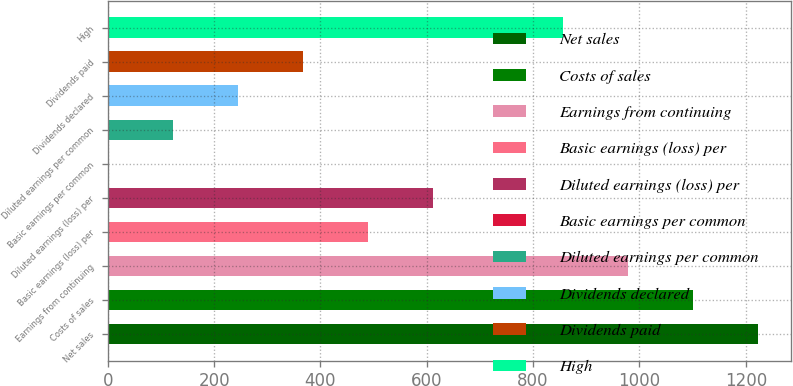Convert chart to OTSL. <chart><loc_0><loc_0><loc_500><loc_500><bar_chart><fcel>Net sales<fcel>Costs of sales<fcel>Earnings from continuing<fcel>Basic earnings (loss) per<fcel>Diluted earnings (loss) per<fcel>Basic earnings per common<fcel>Diluted earnings per common<fcel>Dividends declared<fcel>Dividends paid<fcel>High<nl><fcel>1223.04<fcel>1100.77<fcel>978.5<fcel>489.42<fcel>611.69<fcel>0.34<fcel>122.61<fcel>244.88<fcel>367.15<fcel>856.23<nl></chart> 